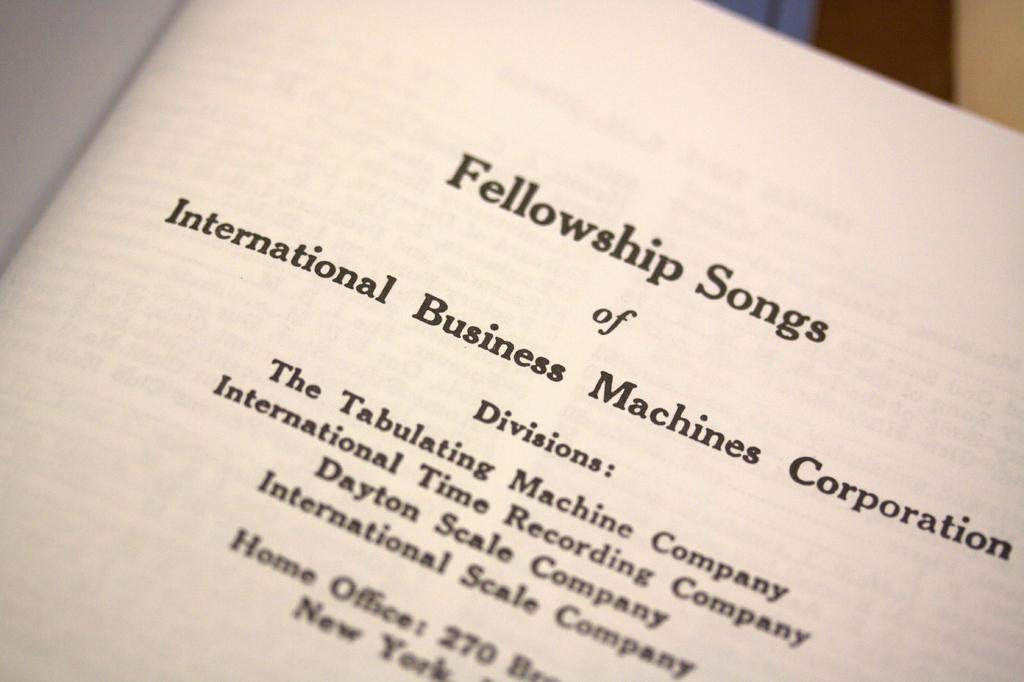Provide a one-sentence caption for the provided image. A book page is titled Fellowship Songs and lists company names. 